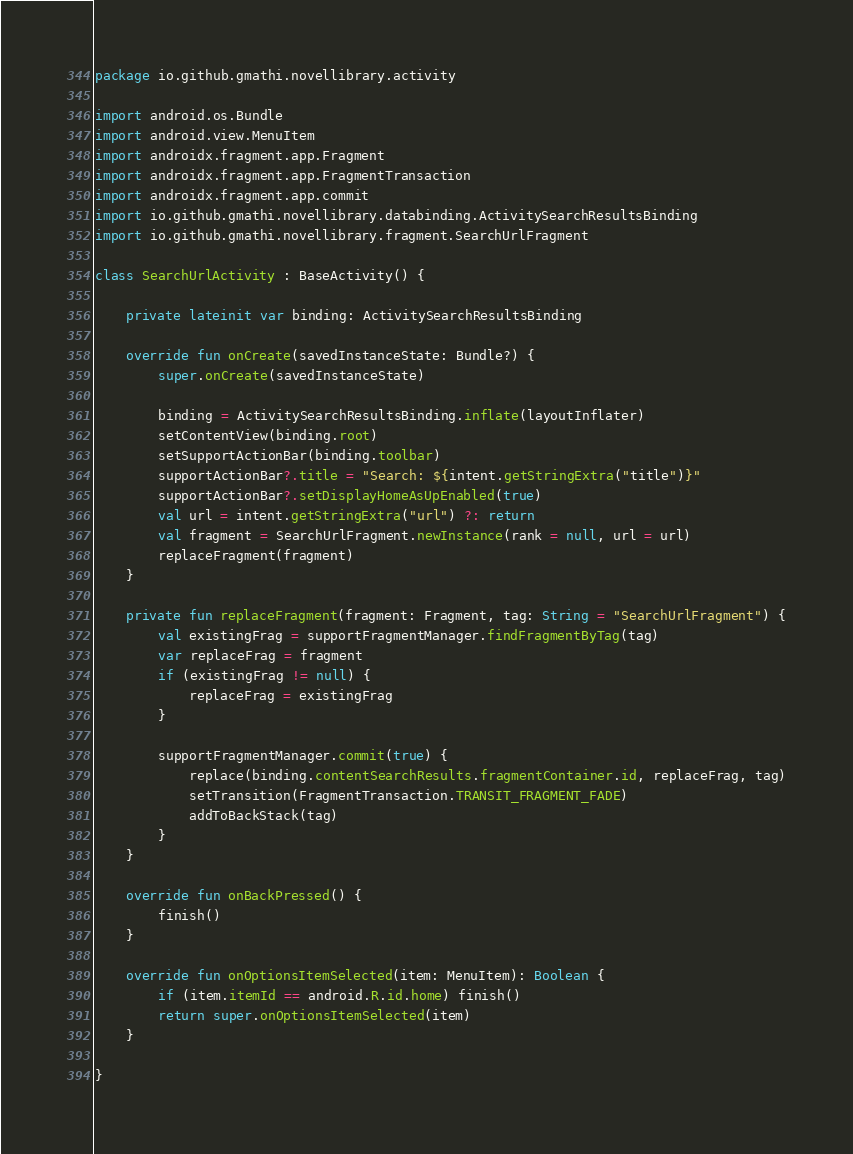Convert code to text. <code><loc_0><loc_0><loc_500><loc_500><_Kotlin_>package io.github.gmathi.novellibrary.activity

import android.os.Bundle
import android.view.MenuItem
import androidx.fragment.app.Fragment
import androidx.fragment.app.FragmentTransaction
import androidx.fragment.app.commit
import io.github.gmathi.novellibrary.databinding.ActivitySearchResultsBinding
import io.github.gmathi.novellibrary.fragment.SearchUrlFragment

class SearchUrlActivity : BaseActivity() {

    private lateinit var binding: ActivitySearchResultsBinding

    override fun onCreate(savedInstanceState: Bundle?) {
        super.onCreate(savedInstanceState)

        binding = ActivitySearchResultsBinding.inflate(layoutInflater)
        setContentView(binding.root)
        setSupportActionBar(binding.toolbar)
        supportActionBar?.title = "Search: ${intent.getStringExtra("title")}"
        supportActionBar?.setDisplayHomeAsUpEnabled(true)
        val url = intent.getStringExtra("url") ?: return
        val fragment = SearchUrlFragment.newInstance(rank = null, url = url)
        replaceFragment(fragment)
    }

    private fun replaceFragment(fragment: Fragment, tag: String = "SearchUrlFragment") {
        val existingFrag = supportFragmentManager.findFragmentByTag(tag)
        var replaceFrag = fragment
        if (existingFrag != null) {
            replaceFrag = existingFrag
        }

        supportFragmentManager.commit(true) {
            replace(binding.contentSearchResults.fragmentContainer.id, replaceFrag, tag)
            setTransition(FragmentTransaction.TRANSIT_FRAGMENT_FADE)
            addToBackStack(tag)
        }
    }

    override fun onBackPressed() {
        finish()
    }

    override fun onOptionsItemSelected(item: MenuItem): Boolean {
        if (item.itemId == android.R.id.home) finish()
        return super.onOptionsItemSelected(item)
    }

}
</code> 